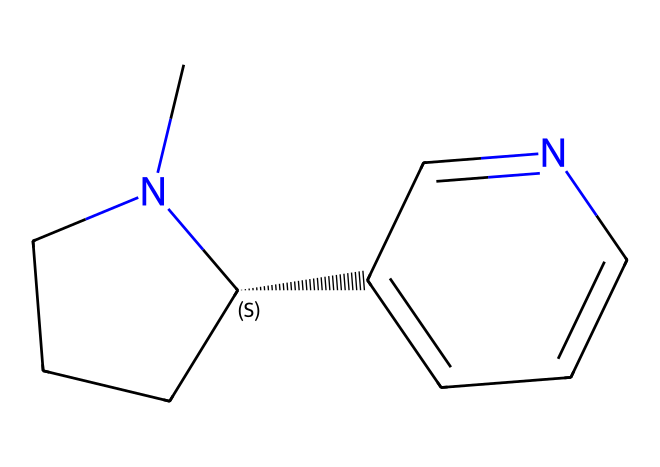What is the molecular formula of nicotine? To find the molecular formula, we can break down the SMILES representation. Counting atoms yields: 10 carbon (C), 14 hydrogen (H), and 2 nitrogen (N). The result is C10H14N2.
Answer: C10H14N2 How many rings are present in the structure of nicotine? The SMILES indicates a bicyclic structure. By identifying the two ring systems in the outline of the molecule, we can conclude that there are two rings present.
Answer: 2 What type of chemical is nicotine classified as? Given its structure, which includes nitrogen atoms and its mechanism of action in the body, nicotine is classified as an alkaloid due to its plant-derived nature and its basic properties.
Answer: alkaloid Which atom in nicotine is responsible for its basic property? The presence of the nitrogen atom in the structure is key because it can accept protons, contributing to its basic characteristics.
Answer: nitrogen How does nicotine primarily affect the nervous system? Nicotine binds to nicotinic acetylcholine receptors, leading to increased dopamine release, which stimulates the reward pathway in the brain and enhances mood, therefore impacting the nervous system significantly.
Answer: dopamine What type of bonding is predominantly found in nicotine's structure? Analyzing the structure reveals that nicotine primarily contains single covalent bonds, which connect the carbon and nitrogen atoms, while also having some double bonds present in the aromatic system.
Answer: covalent bonds 